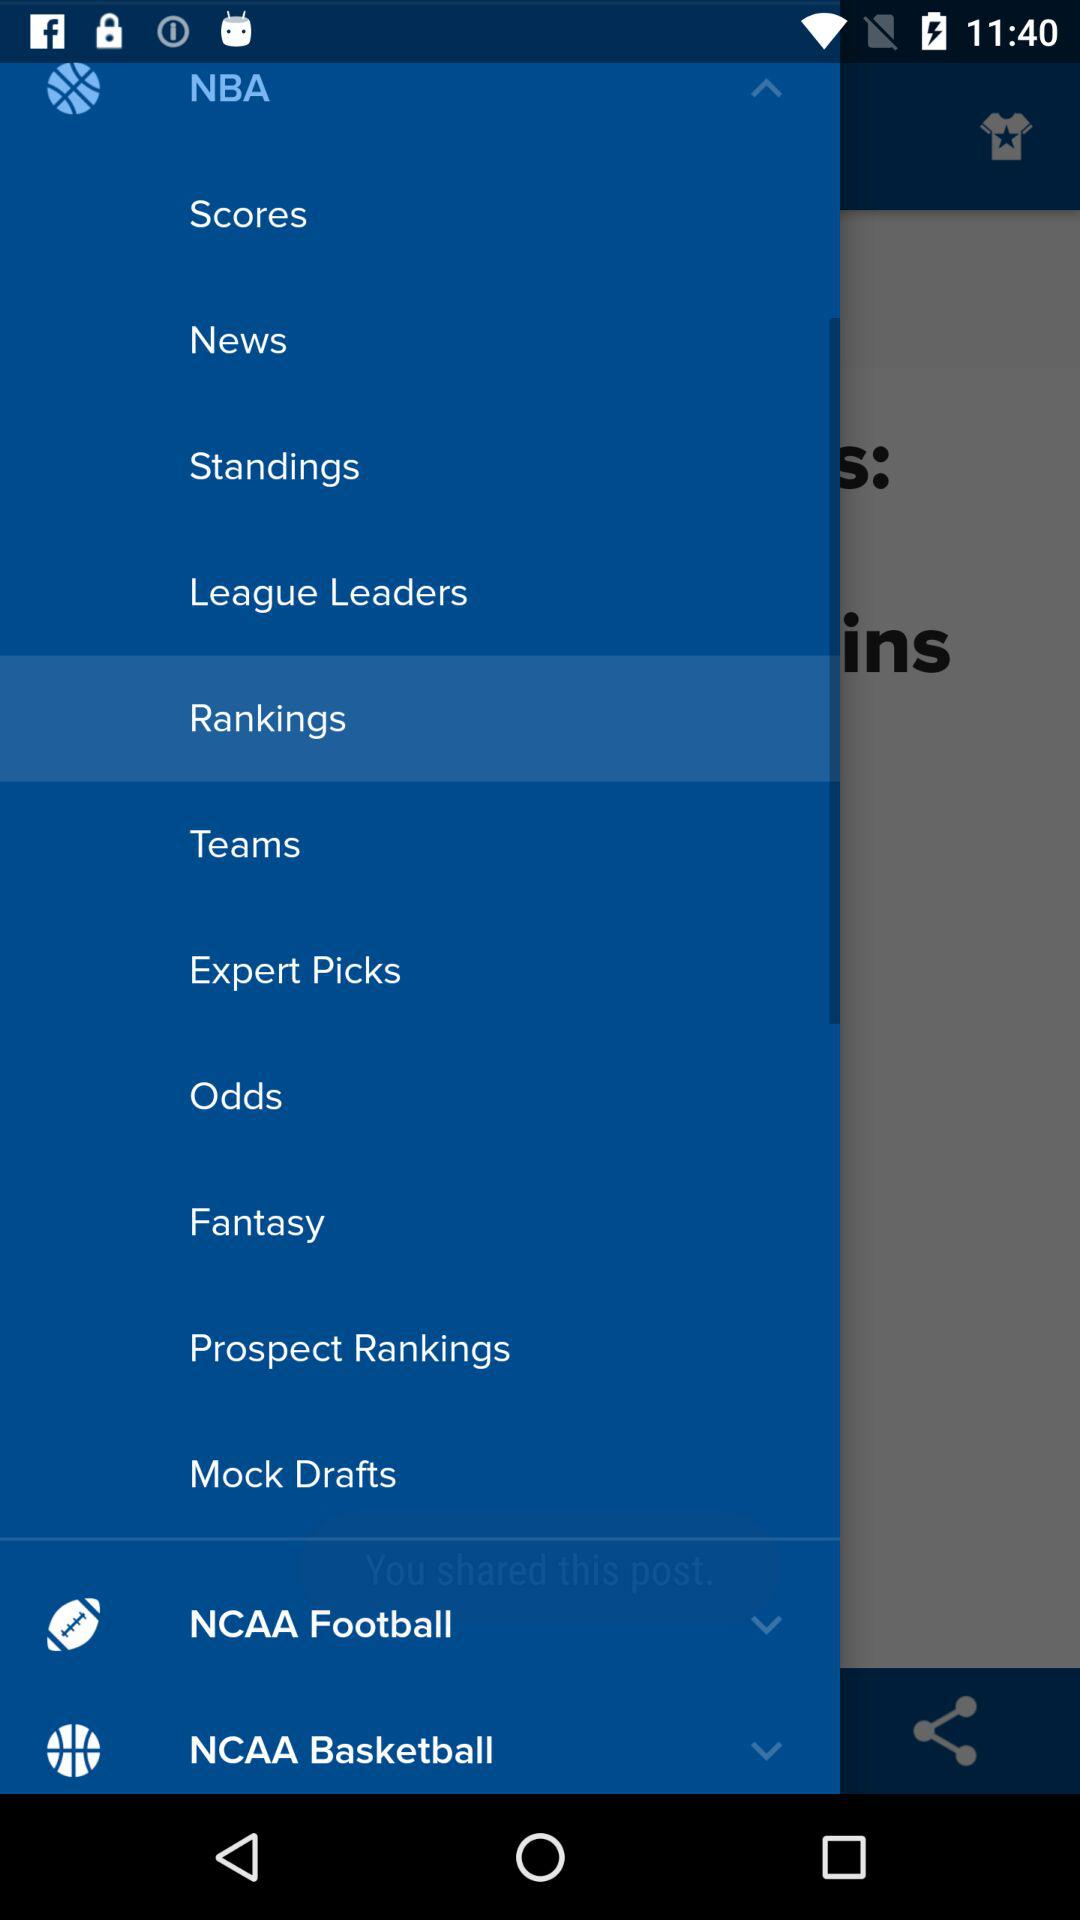What is the name of the application?
When the provided information is insufficient, respond with <no answer>. <no answer> 